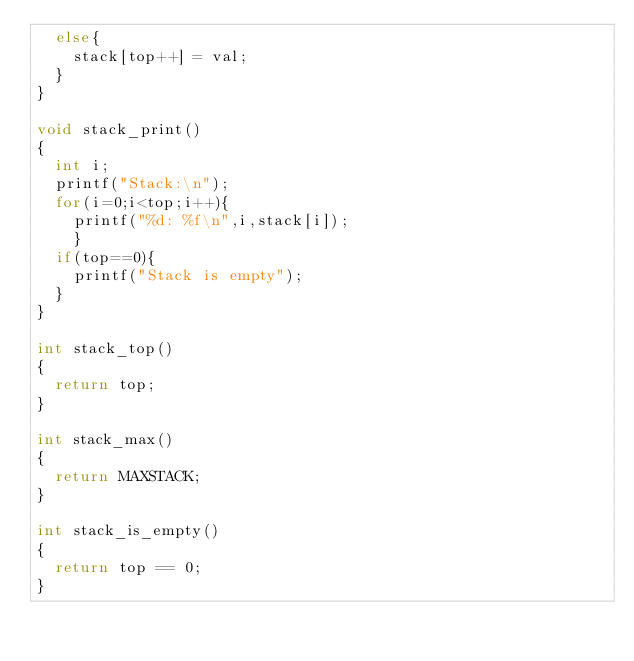<code> <loc_0><loc_0><loc_500><loc_500><_C_>  else{
    stack[top++] = val;
  }
}

void stack_print()
{
  int i;
  printf("Stack:\n");
  for(i=0;i<top;i++){
    printf("%d: %f\n",i,stack[i]);
    }
  if(top==0){
    printf("Stack is empty");
  }
}

int stack_top()
{
  return top;
}

int stack_max()
{
  return MAXSTACK;
}

int stack_is_empty()
{
  return top == 0;
}


</code> 